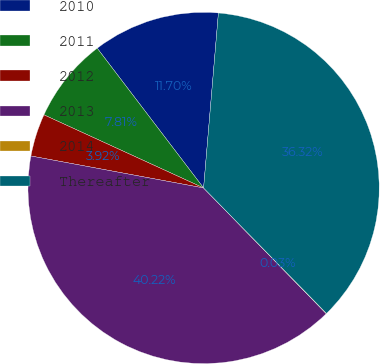<chart> <loc_0><loc_0><loc_500><loc_500><pie_chart><fcel>2010<fcel>2011<fcel>2012<fcel>2013<fcel>2014<fcel>Thereafter<nl><fcel>11.7%<fcel>7.81%<fcel>3.92%<fcel>40.22%<fcel>0.03%<fcel>36.32%<nl></chart> 